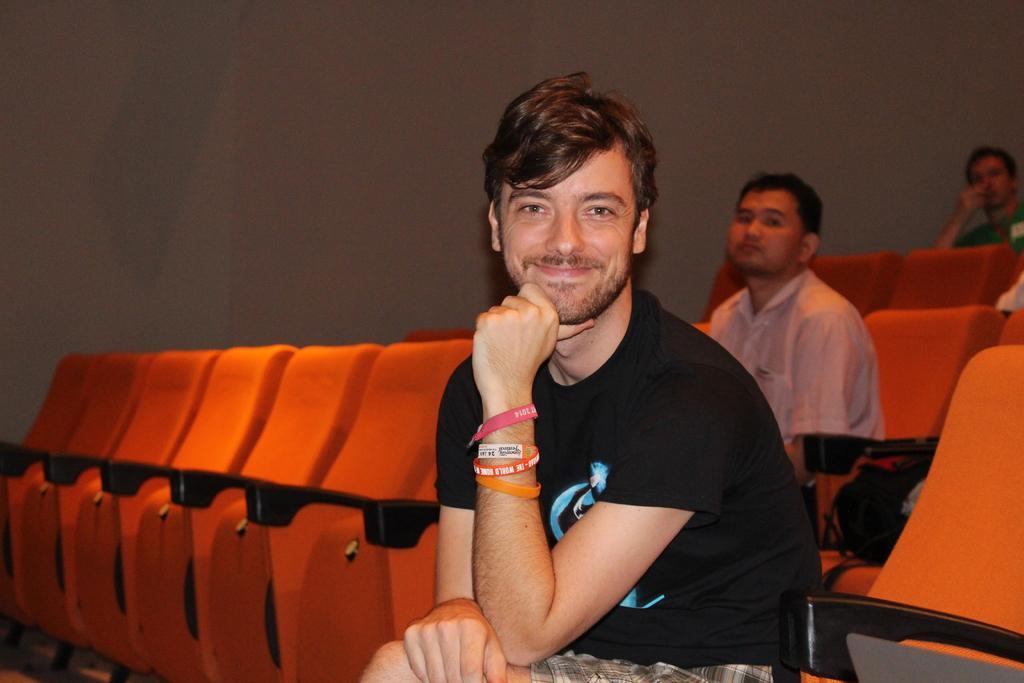Describe this image in one or two sentences. In this picture we can see a group of people sitting on chairs and in the background we can see a wall. 